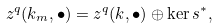<formula> <loc_0><loc_0><loc_500><loc_500>z ^ { q } ( k _ { m } , \bullet ) = z ^ { q } ( k , \bullet ) \oplus \ker s ^ { * } ,</formula> 